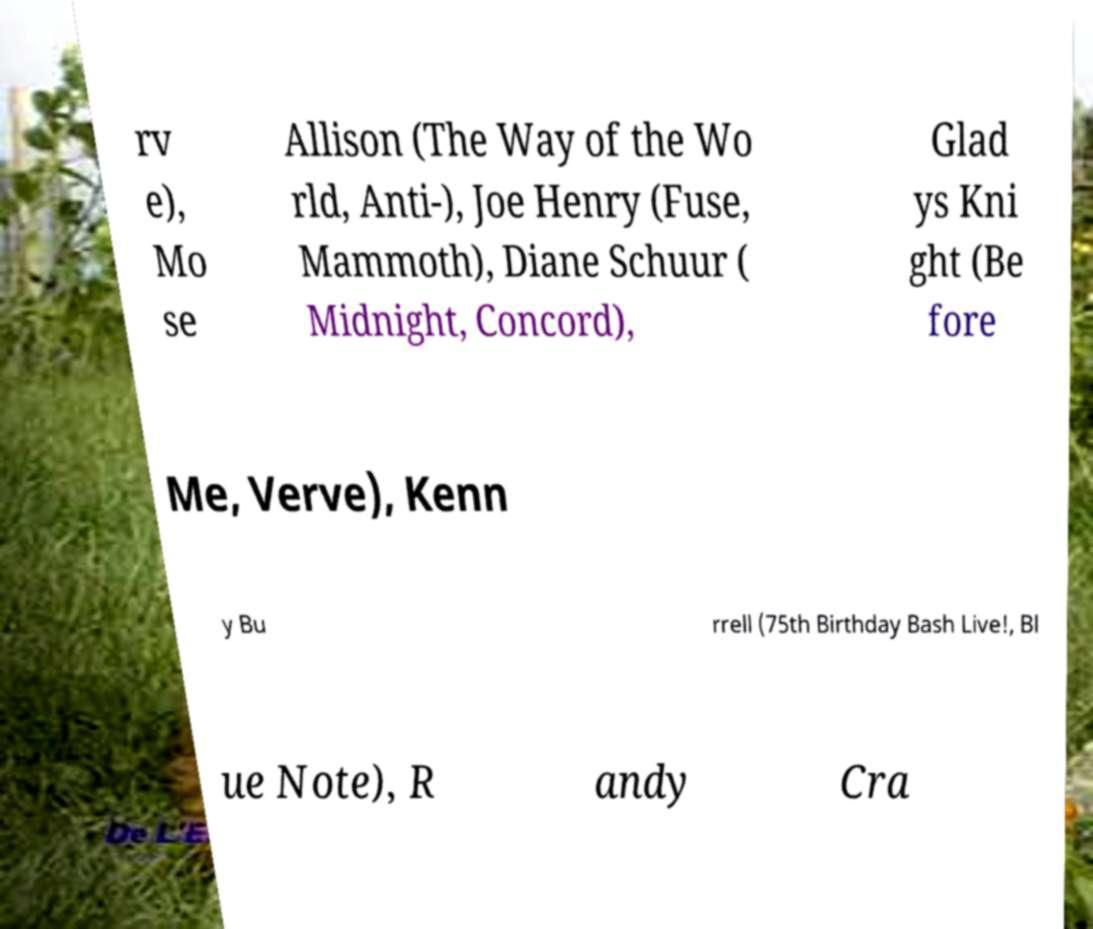Can you accurately transcribe the text from the provided image for me? rv e), Mo se Allison (The Way of the Wo rld, Anti-), Joe Henry (Fuse, Mammoth), Diane Schuur ( Midnight, Concord), Glad ys Kni ght (Be fore Me, Verve), Kenn y Bu rrell (75th Birthday Bash Live!, Bl ue Note), R andy Cra 